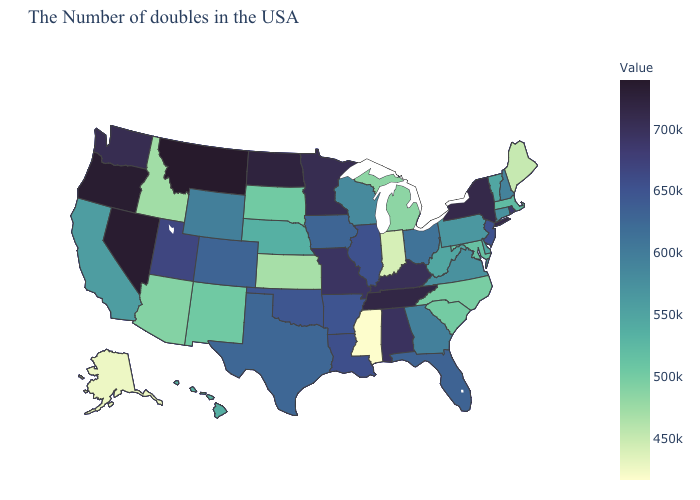Among the states that border Arkansas , does Missouri have the highest value?
Keep it brief. No. Does Mississippi have the lowest value in the USA?
Keep it brief. Yes. Does the map have missing data?
Write a very short answer. No. Does Tennessee have the highest value in the South?
Short answer required. Yes. 